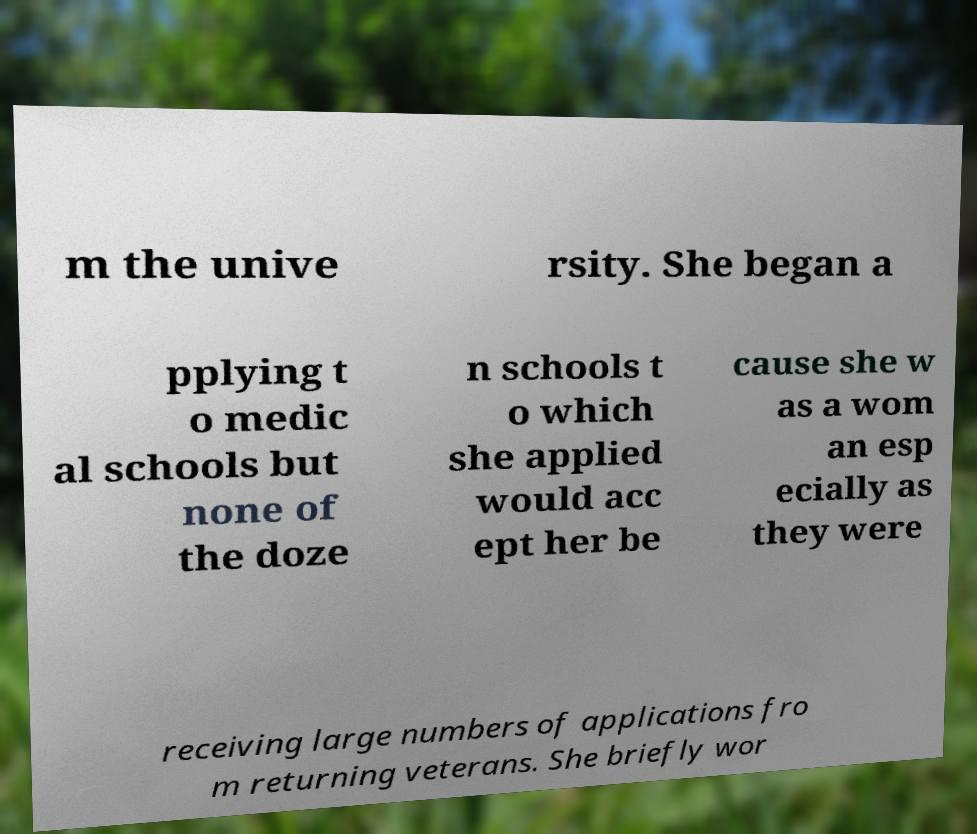Can you read and provide the text displayed in the image?This photo seems to have some interesting text. Can you extract and type it out for me? m the unive rsity. She began a pplying t o medic al schools but none of the doze n schools t o which she applied would acc ept her be cause she w as a wom an esp ecially as they were receiving large numbers of applications fro m returning veterans. She briefly wor 